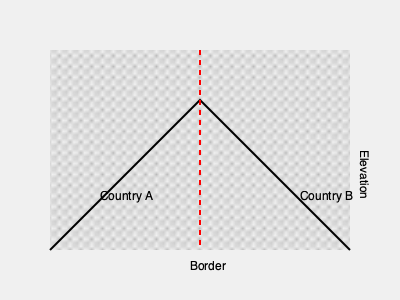Based on the 3D terrain representation shown, which country has a higher average elevation along the international border? To determine which country has a higher average elevation along the international border, we need to analyze the terrain representation:

1. The red dashed line represents the international border between Country A and Country B.
2. The black line represents the terrain profile along the border.
3. The terrain is represented using a topographic pattern, with higher density indicating higher elevation.

Analyzing the terrain profile:
1. On the Country A side (left), the terrain starts high at the border and gradually decreases as it moves away from the border.
2. On the Country B side (right), the terrain starts lower at the border and increases as it moves away from the border.
3. The highest point of the terrain profile is closer to Country A's side of the border.
4. The overall area under the terrain profile is greater on Country A's side.

Given these observations, we can conclude that Country A has a higher average elevation along the international border compared to Country B.
Answer: Country A 